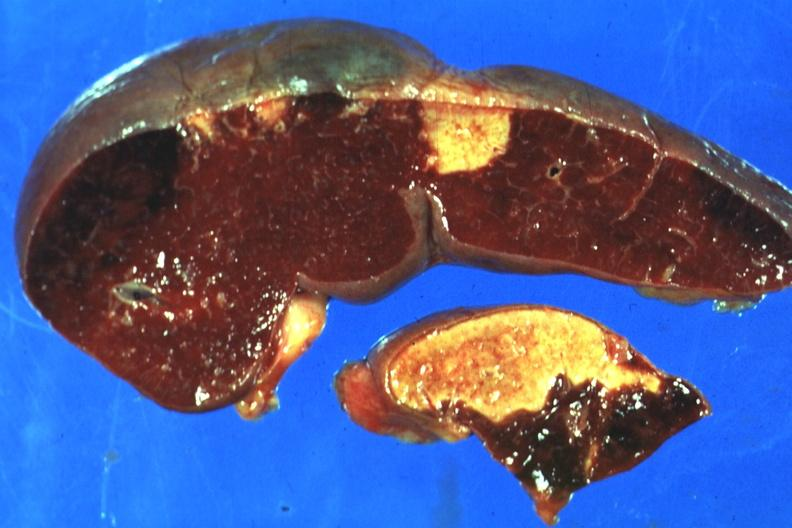does inflamed exocervix show excellent side with four infarcts shown which are several days of age from nonbacterial endocarditis?
Answer the question using a single word or phrase. No 